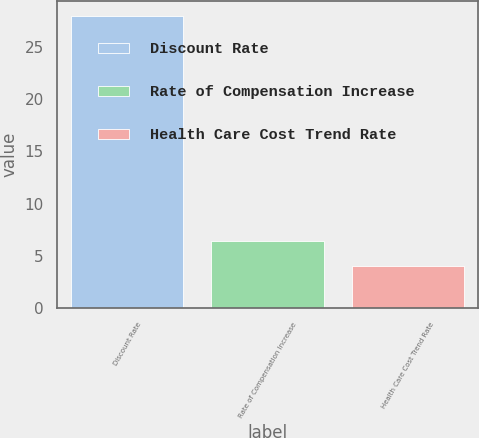Convert chart to OTSL. <chart><loc_0><loc_0><loc_500><loc_500><bar_chart><fcel>Discount Rate<fcel>Rate of Compensation Increase<fcel>Health Care Cost Trend Rate<nl><fcel>28<fcel>6.4<fcel>4<nl></chart> 